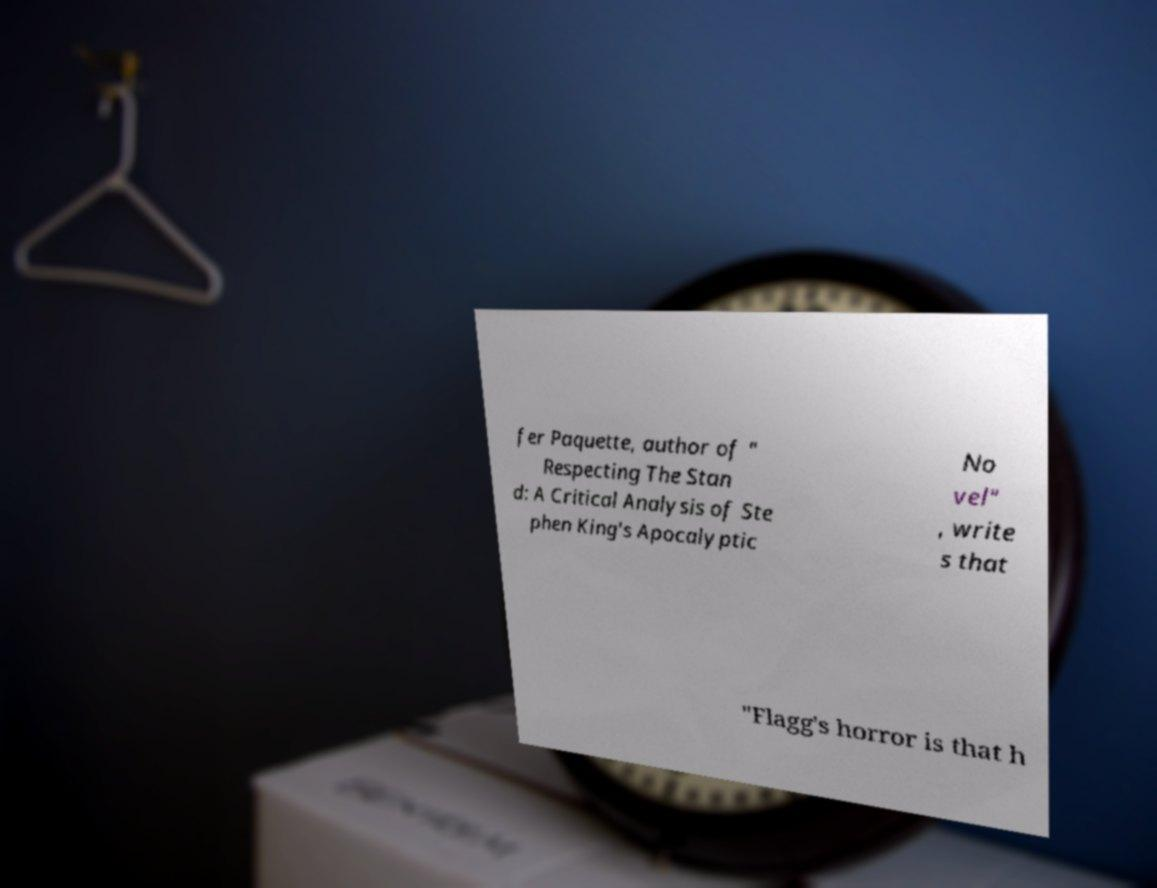Can you read and provide the text displayed in the image?This photo seems to have some interesting text. Can you extract and type it out for me? fer Paquette, author of " Respecting The Stan d: A Critical Analysis of Ste phen King's Apocalyptic No vel" , write s that "Flagg's horror is that h 